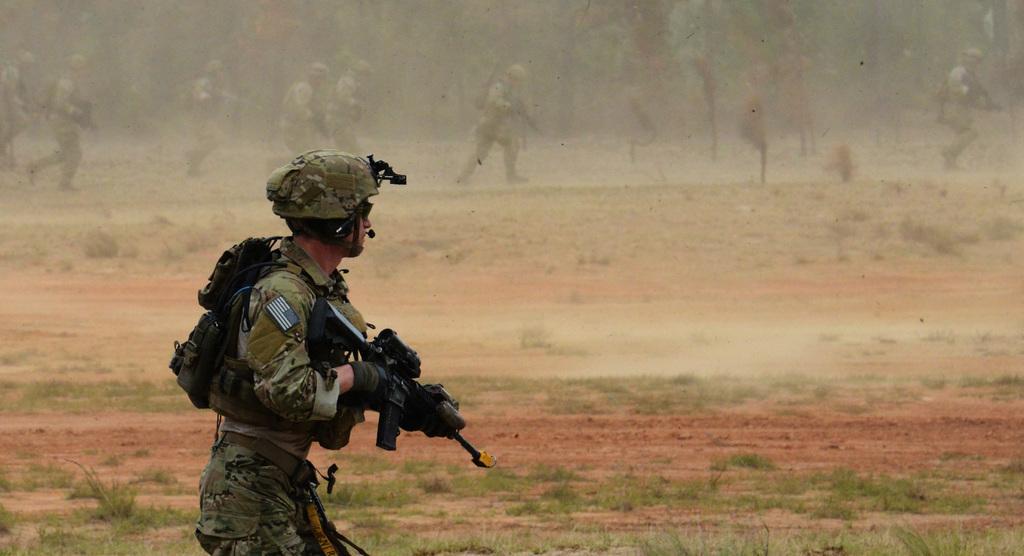How would you summarize this image in a sentence or two? In the image I can see a person who is wearing the backpack and holding the gun and also I can see some other people who are holding the guns. 